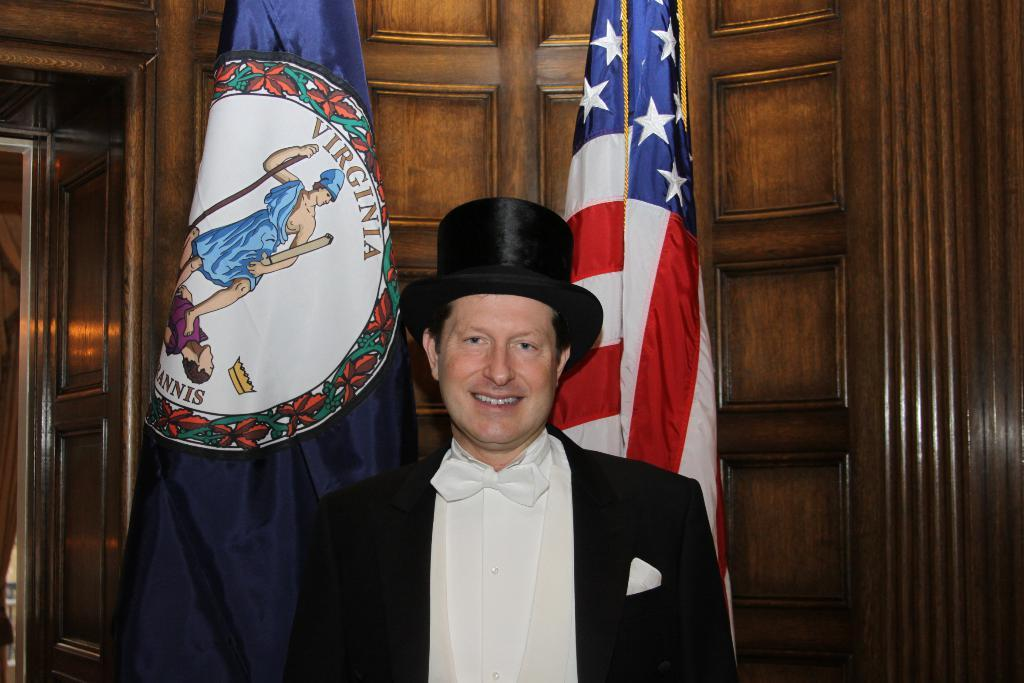What type of wall can be seen in the background of the image? There is a wooden wall in the background of the image. What else is visible in the background of the image? There are flags in the background of the image. Can you describe the man in the image? The man in the image is wearing a black cap and a black blazer. What expression does the man have? The man is smiling. Can you tell me how many waves are visible in the image? There are no waves present in the image. What color are the man's eyes in the image? The color of the man's eyes cannot be determined from the image. 